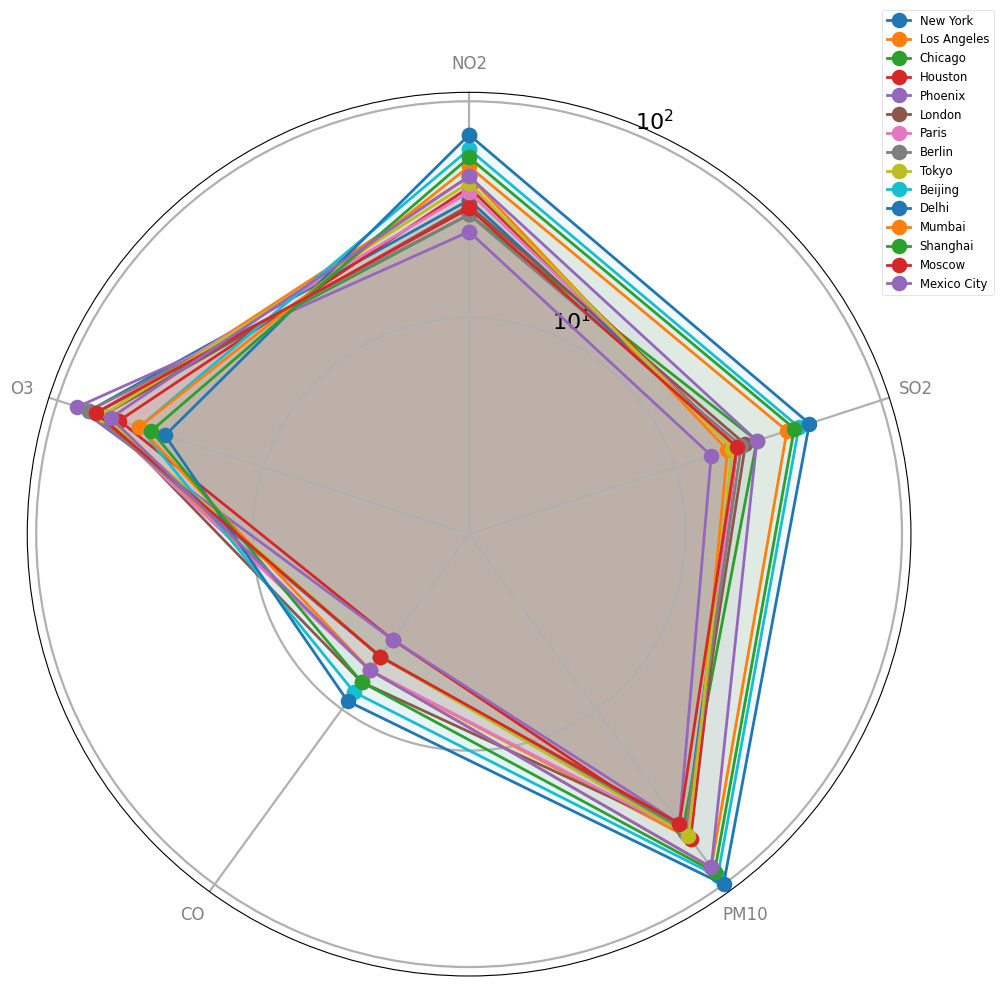What's the highest NO2 value observed across the cities? To determine this, observe the radar chart and look at the spokes corresponding to NO2. The spoke that extends the farthest represents the highest NO2 value. From the chart data, Delhi has the highest NO2 at 70.
Answer: 70 Which city has the smallest PM10 value? Analyze the radar chart, focusing on the PM10 spokes. Identify the city whose spoke is the shortest for PM10. From the chart data, Phoenix and Moscow both have the smallest PM10 value at 45.
Answer: Phoenix and Moscow Compare the CO values of New York and Los Angeles. Which city has a higher CO level? Examine the radar chart, specifically the CO spokes for both New York and Los Angeles. Check which spoke extends further from the center. New York has a CO value of 5, whereas Los Angeles has CO value of 6. Thus, Los Angeles has a higher CO level.
Answer: Los Angeles Which city has the highest combined concentration of NO2 and O3? Add the values for NO2 and O3 for each city and identify the highest sum. For instance, New York has (35+70)=105, Los Angeles has (45+60)=105, etc. Delhi has the highest combined concentration with (70+30)=100.
Answer: New York and Los Angeles Identify the city with the maximum value for SO2. Refer to the radar chart and locate the SO2 spokes. The longest SO2 spoke will indicate the city with the maximum SO2 value. The data shows Delhi has the highest SO2 value at 45.
Answer: Delhi 